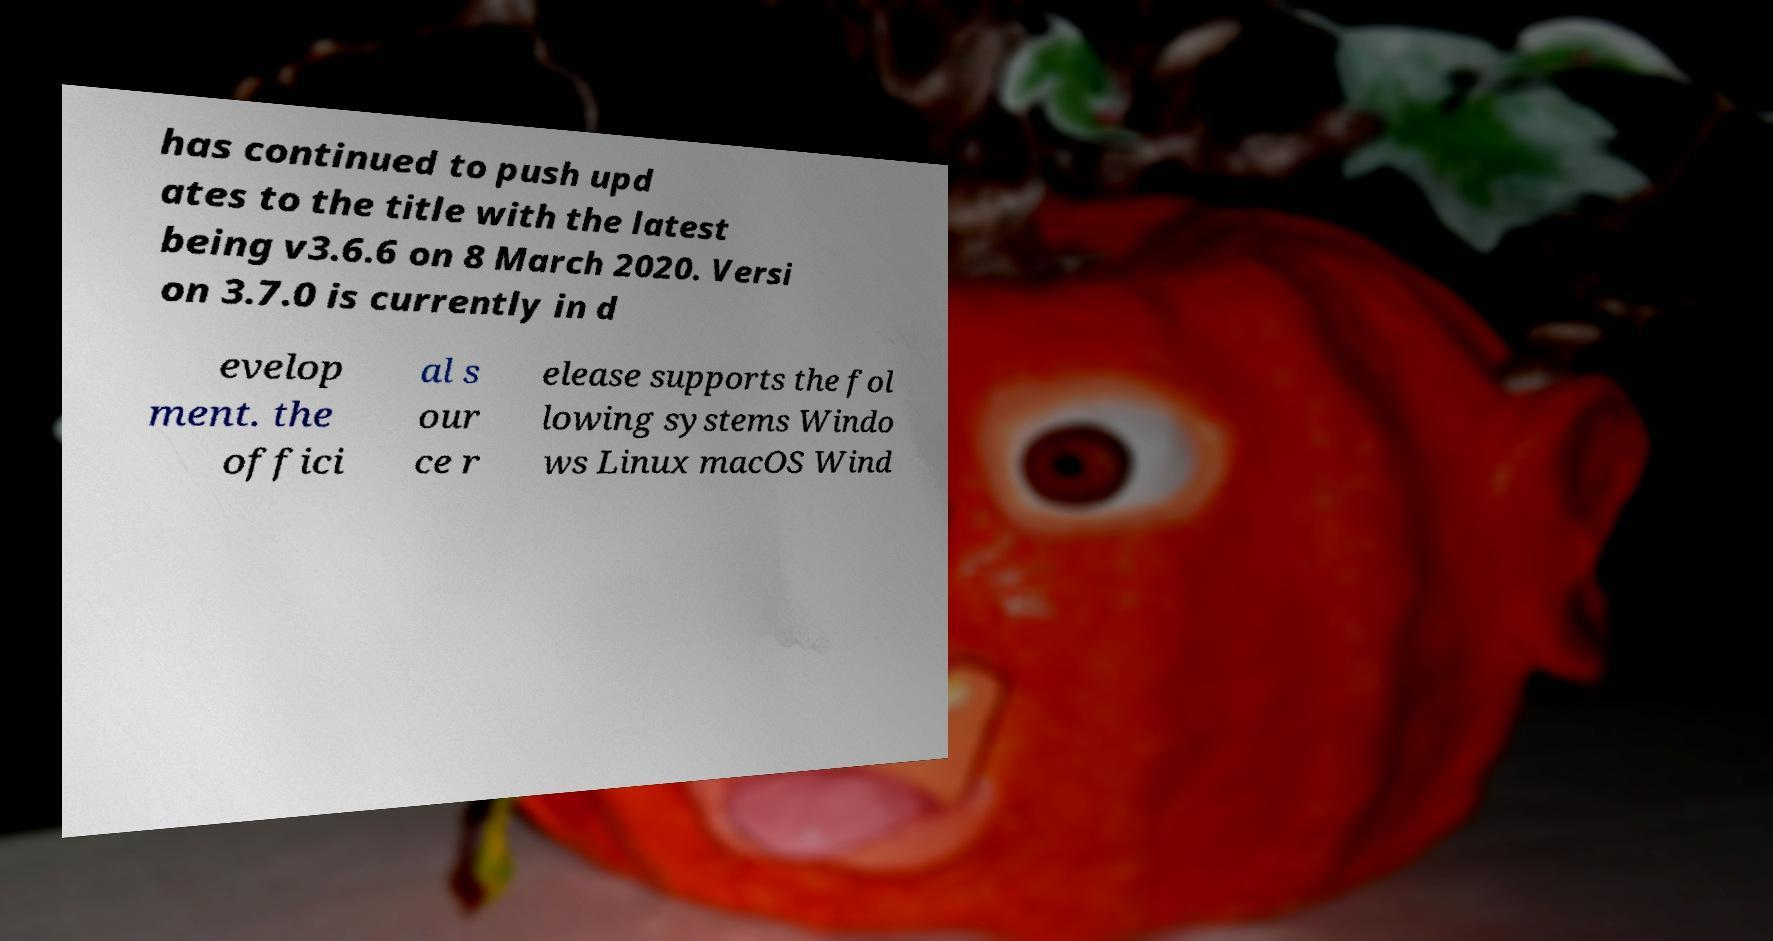I need the written content from this picture converted into text. Can you do that? has continued to push upd ates to the title with the latest being v3.6.6 on 8 March 2020. Versi on 3.7.0 is currently in d evelop ment. the offici al s our ce r elease supports the fol lowing systems Windo ws Linux macOS Wind 